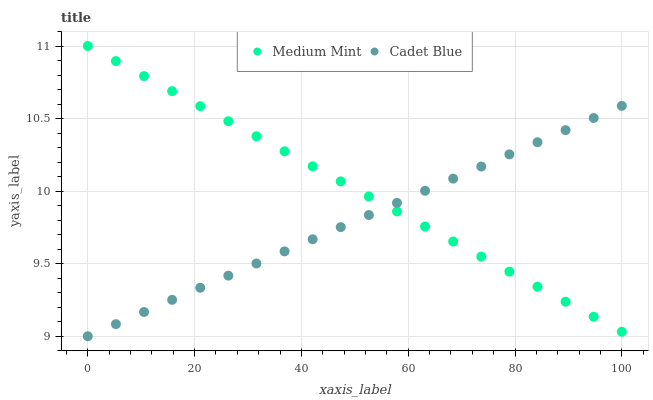Does Cadet Blue have the minimum area under the curve?
Answer yes or no. Yes. Does Medium Mint have the maximum area under the curve?
Answer yes or no. Yes. Does Cadet Blue have the maximum area under the curve?
Answer yes or no. No. Is Medium Mint the smoothest?
Answer yes or no. Yes. Is Cadet Blue the roughest?
Answer yes or no. Yes. Is Cadet Blue the smoothest?
Answer yes or no. No. Does Cadet Blue have the lowest value?
Answer yes or no. Yes. Does Medium Mint have the highest value?
Answer yes or no. Yes. Does Cadet Blue have the highest value?
Answer yes or no. No. Does Medium Mint intersect Cadet Blue?
Answer yes or no. Yes. Is Medium Mint less than Cadet Blue?
Answer yes or no. No. Is Medium Mint greater than Cadet Blue?
Answer yes or no. No. 